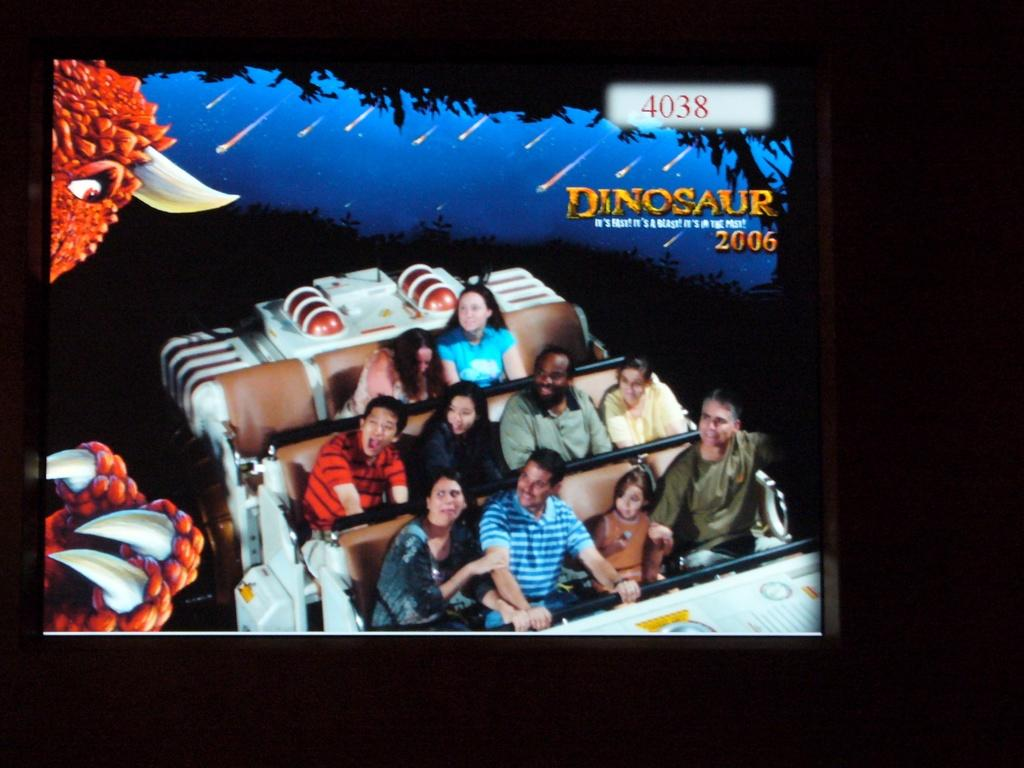<image>
Provide a brief description of the given image. People are riding a roller coaster and it says Dinosaur above them. 